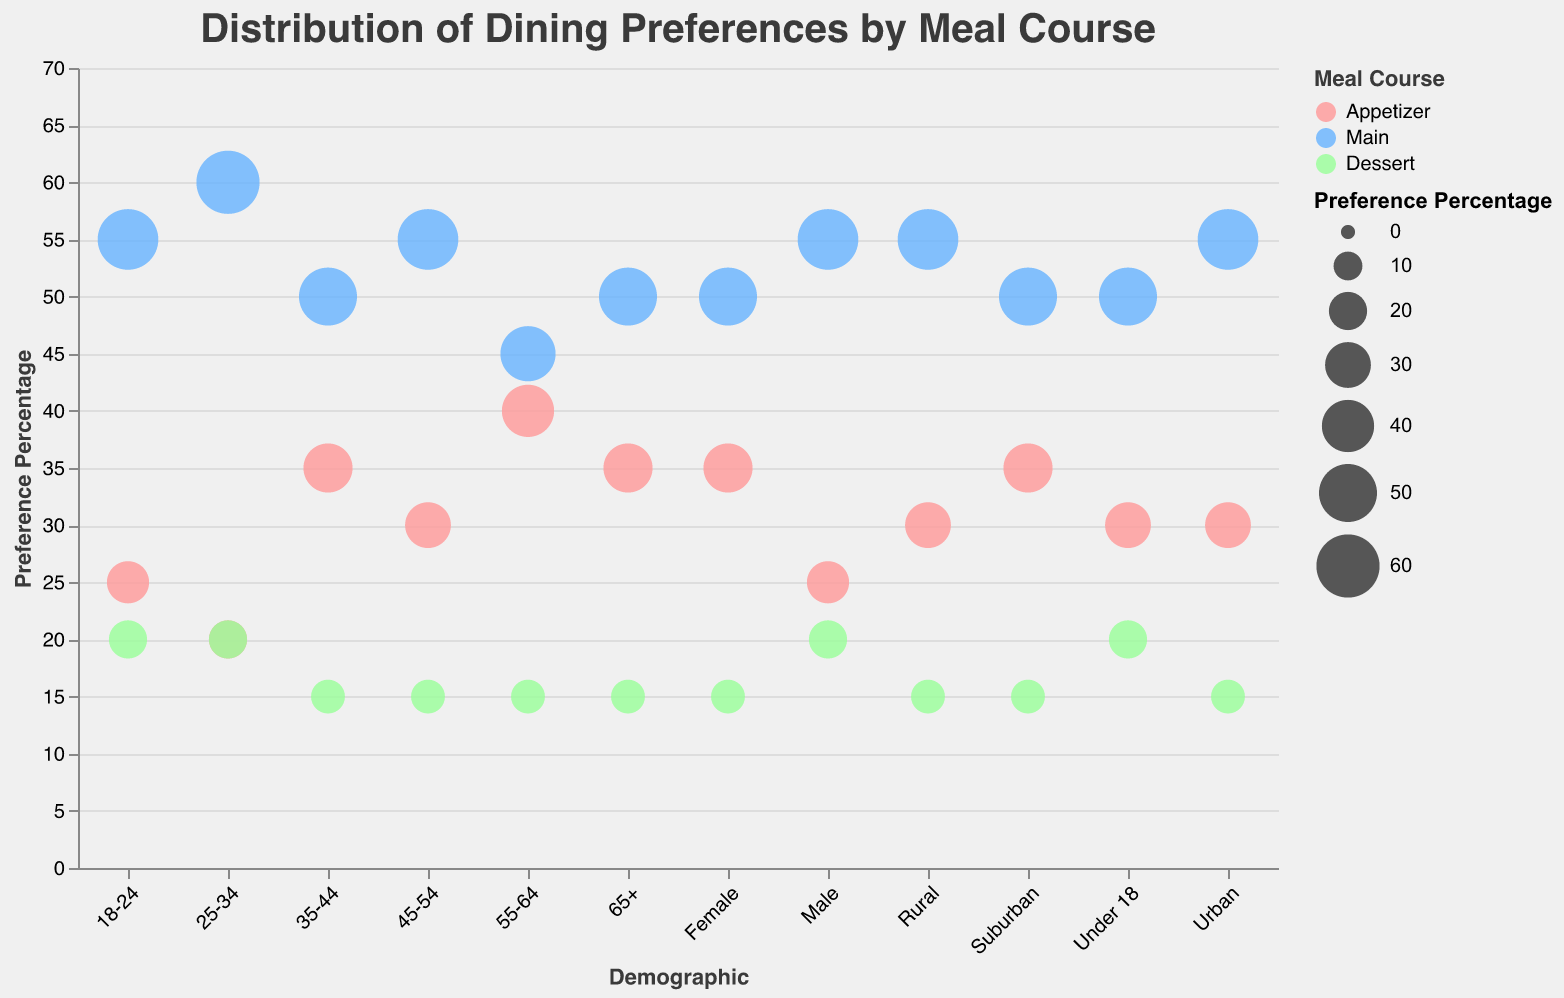What is the title of the chart? The title of the chart is displayed at the top and is typically set in a larger font size to stand out from the rest of the text. Here, the title is "Distribution of Dining Preferences by Meal Course".
Answer: Distribution of Dining Preferences by Meal Course Which meal course has the highest preference percentage among 18-24 age group? To determine this, observe the size of the circles and the y-axis value for the 18-24 demographic. The largest circle for this group is for the "Main" meal course with a preference percentage of 55%.
Answer: Main Which demographic shows the highest preference for appetizers? Look at the y-axis values and the size of the circles. The demographic with the highest value for "Appetizer" is "55-64" with 40%.
Answer: 55-64 Which meal course has a uniform preference percentage across all demographics? Looking at the y-axis values and the color of the circles, "Dessert" has a consistent value of 15-20% across all demographics.
Answer: Dessert What is the difference in preference percentage for mains between male and female demographics? The "Main" preference percentage is 55% for males and 50% for females. The difference is calculated by subtracting the smaller value from the larger value: 55% - 50% = 5%.
Answer: 5% What is the total preference percentage for all meal courses in the 25-34 age group? Add the preference percentages for appetizers, mains, and desserts in the 25-34 age group: 20% (Appetizer) + 60% (Main) + 20% (Dessert) = 100%.
Answer: 100% Which demographic has the lowest preference percentage for desserts, and what is the percentage? By comparing the y-axis values for the "Dessert" meal course across all demographics, the lowest preference percentage is 15% for multiple demographics including 35-44, 45-54, 55-64, 65+, Female, Urban, Suburban, and Rural.
Answer: Multiple demographics (including 35-44, 45-54, 55-64, 65+, Female, Urban, Suburban, and Rural) with 15% Which demographic shows the highest preference for the main course and what is the percentage? By observing the circles corresponding to the "Main" course, the demographic "25-34" has the highest preference percentage of 60%.
Answer: 25-34, 60% What is the difference in preference for appetizers between the 'Under 18' and '35-44' demographics? The preference percentage for appetizers is 30% for "Under 18" and 35% for "35-44". The difference is 35% - 30% = 5%.
Answer: 5% 